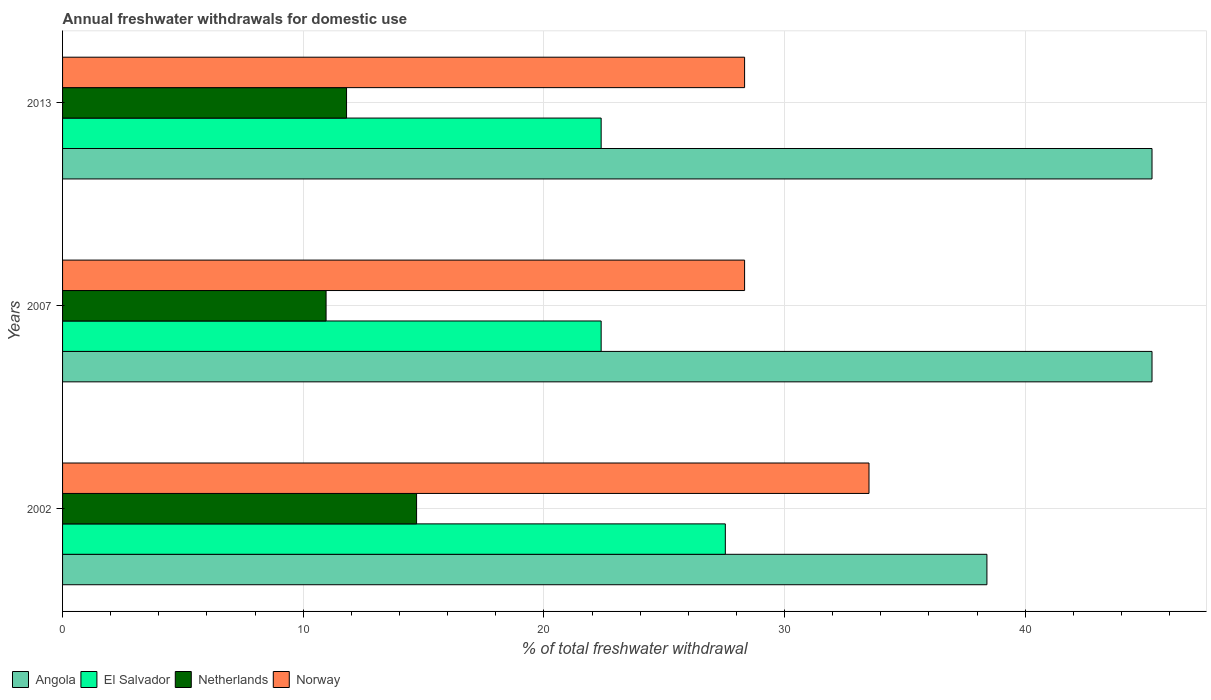How many different coloured bars are there?
Your response must be concise. 4. Are the number of bars per tick equal to the number of legend labels?
Offer a terse response. Yes. How many bars are there on the 1st tick from the top?
Your response must be concise. 4. In how many cases, is the number of bars for a given year not equal to the number of legend labels?
Keep it short and to the point. 0. What is the total annual withdrawals from freshwater in El Salvador in 2013?
Make the answer very short. 22.38. Across all years, what is the maximum total annual withdrawals from freshwater in Netherlands?
Offer a very short reply. 14.71. Across all years, what is the minimum total annual withdrawals from freshwater in Netherlands?
Provide a short and direct response. 10.95. In which year was the total annual withdrawals from freshwater in Norway maximum?
Ensure brevity in your answer.  2002. In which year was the total annual withdrawals from freshwater in El Salvador minimum?
Provide a short and direct response. 2007. What is the total total annual withdrawals from freshwater in Angola in the graph?
Make the answer very short. 128.95. What is the difference between the total annual withdrawals from freshwater in El Salvador in 2007 and that in 2013?
Give a very brief answer. 0. What is the difference between the total annual withdrawals from freshwater in Angola in 2007 and the total annual withdrawals from freshwater in Norway in 2002?
Your response must be concise. 11.76. What is the average total annual withdrawals from freshwater in El Salvador per year?
Give a very brief answer. 24.1. In the year 2007, what is the difference between the total annual withdrawals from freshwater in El Salvador and total annual withdrawals from freshwater in Norway?
Offer a terse response. -5.96. In how many years, is the total annual withdrawals from freshwater in Netherlands greater than 34 %?
Your response must be concise. 0. What is the ratio of the total annual withdrawals from freshwater in Angola in 2007 to that in 2013?
Provide a short and direct response. 1. Is the difference between the total annual withdrawals from freshwater in El Salvador in 2007 and 2013 greater than the difference between the total annual withdrawals from freshwater in Norway in 2007 and 2013?
Offer a terse response. No. What is the difference between the highest and the second highest total annual withdrawals from freshwater in Norway?
Offer a very short reply. 5.17. What is the difference between the highest and the lowest total annual withdrawals from freshwater in Norway?
Make the answer very short. 5.17. What does the 3rd bar from the top in 2002 represents?
Ensure brevity in your answer.  El Salvador. How many bars are there?
Your response must be concise. 12. Are all the bars in the graph horizontal?
Give a very brief answer. Yes. Are the values on the major ticks of X-axis written in scientific E-notation?
Provide a succinct answer. No. Where does the legend appear in the graph?
Keep it short and to the point. Bottom left. How are the legend labels stacked?
Your answer should be compact. Horizontal. What is the title of the graph?
Provide a short and direct response. Annual freshwater withdrawals for domestic use. What is the label or title of the X-axis?
Provide a succinct answer. % of total freshwater withdrawal. What is the label or title of the Y-axis?
Your answer should be very brief. Years. What is the % of total freshwater withdrawal of Angola in 2002?
Offer a very short reply. 38.41. What is the % of total freshwater withdrawal of El Salvador in 2002?
Your answer should be very brief. 27.54. What is the % of total freshwater withdrawal of Netherlands in 2002?
Offer a very short reply. 14.71. What is the % of total freshwater withdrawal of Norway in 2002?
Your answer should be very brief. 33.51. What is the % of total freshwater withdrawal in Angola in 2007?
Your answer should be compact. 45.27. What is the % of total freshwater withdrawal in El Salvador in 2007?
Provide a succinct answer. 22.38. What is the % of total freshwater withdrawal in Netherlands in 2007?
Ensure brevity in your answer.  10.95. What is the % of total freshwater withdrawal in Norway in 2007?
Provide a succinct answer. 28.34. What is the % of total freshwater withdrawal of Angola in 2013?
Offer a very short reply. 45.27. What is the % of total freshwater withdrawal of El Salvador in 2013?
Your response must be concise. 22.38. What is the % of total freshwater withdrawal of Netherlands in 2013?
Make the answer very short. 11.8. What is the % of total freshwater withdrawal in Norway in 2013?
Your answer should be very brief. 28.34. Across all years, what is the maximum % of total freshwater withdrawal in Angola?
Offer a very short reply. 45.27. Across all years, what is the maximum % of total freshwater withdrawal in El Salvador?
Make the answer very short. 27.54. Across all years, what is the maximum % of total freshwater withdrawal of Netherlands?
Your answer should be compact. 14.71. Across all years, what is the maximum % of total freshwater withdrawal of Norway?
Your response must be concise. 33.51. Across all years, what is the minimum % of total freshwater withdrawal in Angola?
Offer a very short reply. 38.41. Across all years, what is the minimum % of total freshwater withdrawal in El Salvador?
Make the answer very short. 22.38. Across all years, what is the minimum % of total freshwater withdrawal of Netherlands?
Your answer should be compact. 10.95. Across all years, what is the minimum % of total freshwater withdrawal of Norway?
Make the answer very short. 28.34. What is the total % of total freshwater withdrawal in Angola in the graph?
Ensure brevity in your answer.  128.95. What is the total % of total freshwater withdrawal of El Salvador in the graph?
Provide a short and direct response. 72.3. What is the total % of total freshwater withdrawal in Netherlands in the graph?
Your answer should be compact. 37.46. What is the total % of total freshwater withdrawal in Norway in the graph?
Keep it short and to the point. 90.19. What is the difference between the % of total freshwater withdrawal of Angola in 2002 and that in 2007?
Give a very brief answer. -6.86. What is the difference between the % of total freshwater withdrawal of El Salvador in 2002 and that in 2007?
Give a very brief answer. 5.16. What is the difference between the % of total freshwater withdrawal in Netherlands in 2002 and that in 2007?
Keep it short and to the point. 3.76. What is the difference between the % of total freshwater withdrawal in Norway in 2002 and that in 2007?
Give a very brief answer. 5.17. What is the difference between the % of total freshwater withdrawal in Angola in 2002 and that in 2013?
Keep it short and to the point. -6.86. What is the difference between the % of total freshwater withdrawal in El Salvador in 2002 and that in 2013?
Provide a succinct answer. 5.16. What is the difference between the % of total freshwater withdrawal in Netherlands in 2002 and that in 2013?
Keep it short and to the point. 2.91. What is the difference between the % of total freshwater withdrawal of Norway in 2002 and that in 2013?
Offer a very short reply. 5.17. What is the difference between the % of total freshwater withdrawal of Angola in 2007 and that in 2013?
Your response must be concise. 0. What is the difference between the % of total freshwater withdrawal of Netherlands in 2007 and that in 2013?
Your answer should be very brief. -0.85. What is the difference between the % of total freshwater withdrawal in Norway in 2007 and that in 2013?
Make the answer very short. 0. What is the difference between the % of total freshwater withdrawal of Angola in 2002 and the % of total freshwater withdrawal of El Salvador in 2007?
Your answer should be compact. 16.03. What is the difference between the % of total freshwater withdrawal of Angola in 2002 and the % of total freshwater withdrawal of Netherlands in 2007?
Give a very brief answer. 27.46. What is the difference between the % of total freshwater withdrawal in Angola in 2002 and the % of total freshwater withdrawal in Norway in 2007?
Your response must be concise. 10.07. What is the difference between the % of total freshwater withdrawal in El Salvador in 2002 and the % of total freshwater withdrawal in Netherlands in 2007?
Your response must be concise. 16.59. What is the difference between the % of total freshwater withdrawal of El Salvador in 2002 and the % of total freshwater withdrawal of Norway in 2007?
Offer a terse response. -0.8. What is the difference between the % of total freshwater withdrawal of Netherlands in 2002 and the % of total freshwater withdrawal of Norway in 2007?
Your answer should be compact. -13.63. What is the difference between the % of total freshwater withdrawal of Angola in 2002 and the % of total freshwater withdrawal of El Salvador in 2013?
Make the answer very short. 16.03. What is the difference between the % of total freshwater withdrawal in Angola in 2002 and the % of total freshwater withdrawal in Netherlands in 2013?
Ensure brevity in your answer.  26.61. What is the difference between the % of total freshwater withdrawal in Angola in 2002 and the % of total freshwater withdrawal in Norway in 2013?
Provide a succinct answer. 10.07. What is the difference between the % of total freshwater withdrawal in El Salvador in 2002 and the % of total freshwater withdrawal in Netherlands in 2013?
Provide a short and direct response. 15.74. What is the difference between the % of total freshwater withdrawal of Netherlands in 2002 and the % of total freshwater withdrawal of Norway in 2013?
Provide a short and direct response. -13.63. What is the difference between the % of total freshwater withdrawal of Angola in 2007 and the % of total freshwater withdrawal of El Salvador in 2013?
Keep it short and to the point. 22.89. What is the difference between the % of total freshwater withdrawal in Angola in 2007 and the % of total freshwater withdrawal in Netherlands in 2013?
Provide a short and direct response. 33.47. What is the difference between the % of total freshwater withdrawal in Angola in 2007 and the % of total freshwater withdrawal in Norway in 2013?
Provide a short and direct response. 16.93. What is the difference between the % of total freshwater withdrawal of El Salvador in 2007 and the % of total freshwater withdrawal of Netherlands in 2013?
Provide a short and direct response. 10.58. What is the difference between the % of total freshwater withdrawal in El Salvador in 2007 and the % of total freshwater withdrawal in Norway in 2013?
Ensure brevity in your answer.  -5.96. What is the difference between the % of total freshwater withdrawal of Netherlands in 2007 and the % of total freshwater withdrawal of Norway in 2013?
Your answer should be compact. -17.39. What is the average % of total freshwater withdrawal in Angola per year?
Provide a short and direct response. 42.98. What is the average % of total freshwater withdrawal in El Salvador per year?
Your answer should be compact. 24.1. What is the average % of total freshwater withdrawal in Netherlands per year?
Offer a very short reply. 12.49. What is the average % of total freshwater withdrawal in Norway per year?
Ensure brevity in your answer.  30.06. In the year 2002, what is the difference between the % of total freshwater withdrawal of Angola and % of total freshwater withdrawal of El Salvador?
Offer a terse response. 10.87. In the year 2002, what is the difference between the % of total freshwater withdrawal in Angola and % of total freshwater withdrawal in Netherlands?
Your answer should be compact. 23.7. In the year 2002, what is the difference between the % of total freshwater withdrawal in El Salvador and % of total freshwater withdrawal in Netherlands?
Your answer should be compact. 12.83. In the year 2002, what is the difference between the % of total freshwater withdrawal of El Salvador and % of total freshwater withdrawal of Norway?
Provide a short and direct response. -5.97. In the year 2002, what is the difference between the % of total freshwater withdrawal of Netherlands and % of total freshwater withdrawal of Norway?
Offer a terse response. -18.8. In the year 2007, what is the difference between the % of total freshwater withdrawal in Angola and % of total freshwater withdrawal in El Salvador?
Give a very brief answer. 22.89. In the year 2007, what is the difference between the % of total freshwater withdrawal in Angola and % of total freshwater withdrawal in Netherlands?
Your response must be concise. 34.32. In the year 2007, what is the difference between the % of total freshwater withdrawal in Angola and % of total freshwater withdrawal in Norway?
Your answer should be very brief. 16.93. In the year 2007, what is the difference between the % of total freshwater withdrawal of El Salvador and % of total freshwater withdrawal of Netherlands?
Offer a terse response. 11.43. In the year 2007, what is the difference between the % of total freshwater withdrawal in El Salvador and % of total freshwater withdrawal in Norway?
Make the answer very short. -5.96. In the year 2007, what is the difference between the % of total freshwater withdrawal of Netherlands and % of total freshwater withdrawal of Norway?
Ensure brevity in your answer.  -17.39. In the year 2013, what is the difference between the % of total freshwater withdrawal of Angola and % of total freshwater withdrawal of El Salvador?
Ensure brevity in your answer.  22.89. In the year 2013, what is the difference between the % of total freshwater withdrawal of Angola and % of total freshwater withdrawal of Netherlands?
Offer a very short reply. 33.47. In the year 2013, what is the difference between the % of total freshwater withdrawal of Angola and % of total freshwater withdrawal of Norway?
Keep it short and to the point. 16.93. In the year 2013, what is the difference between the % of total freshwater withdrawal in El Salvador and % of total freshwater withdrawal in Netherlands?
Ensure brevity in your answer.  10.58. In the year 2013, what is the difference between the % of total freshwater withdrawal of El Salvador and % of total freshwater withdrawal of Norway?
Your response must be concise. -5.96. In the year 2013, what is the difference between the % of total freshwater withdrawal in Netherlands and % of total freshwater withdrawal in Norway?
Provide a short and direct response. -16.54. What is the ratio of the % of total freshwater withdrawal of Angola in 2002 to that in 2007?
Make the answer very short. 0.85. What is the ratio of the % of total freshwater withdrawal in El Salvador in 2002 to that in 2007?
Your answer should be compact. 1.23. What is the ratio of the % of total freshwater withdrawal in Netherlands in 2002 to that in 2007?
Provide a succinct answer. 1.34. What is the ratio of the % of total freshwater withdrawal of Norway in 2002 to that in 2007?
Offer a terse response. 1.18. What is the ratio of the % of total freshwater withdrawal in Angola in 2002 to that in 2013?
Keep it short and to the point. 0.85. What is the ratio of the % of total freshwater withdrawal in El Salvador in 2002 to that in 2013?
Offer a very short reply. 1.23. What is the ratio of the % of total freshwater withdrawal of Netherlands in 2002 to that in 2013?
Provide a short and direct response. 1.25. What is the ratio of the % of total freshwater withdrawal of Norway in 2002 to that in 2013?
Offer a very short reply. 1.18. What is the ratio of the % of total freshwater withdrawal of Angola in 2007 to that in 2013?
Ensure brevity in your answer.  1. What is the ratio of the % of total freshwater withdrawal of El Salvador in 2007 to that in 2013?
Give a very brief answer. 1. What is the ratio of the % of total freshwater withdrawal of Netherlands in 2007 to that in 2013?
Offer a very short reply. 0.93. What is the ratio of the % of total freshwater withdrawal of Norway in 2007 to that in 2013?
Ensure brevity in your answer.  1. What is the difference between the highest and the second highest % of total freshwater withdrawal of Angola?
Make the answer very short. 0. What is the difference between the highest and the second highest % of total freshwater withdrawal in El Salvador?
Offer a terse response. 5.16. What is the difference between the highest and the second highest % of total freshwater withdrawal of Netherlands?
Your answer should be very brief. 2.91. What is the difference between the highest and the second highest % of total freshwater withdrawal of Norway?
Keep it short and to the point. 5.17. What is the difference between the highest and the lowest % of total freshwater withdrawal in Angola?
Make the answer very short. 6.86. What is the difference between the highest and the lowest % of total freshwater withdrawal in El Salvador?
Make the answer very short. 5.16. What is the difference between the highest and the lowest % of total freshwater withdrawal of Netherlands?
Your answer should be compact. 3.76. What is the difference between the highest and the lowest % of total freshwater withdrawal of Norway?
Offer a very short reply. 5.17. 